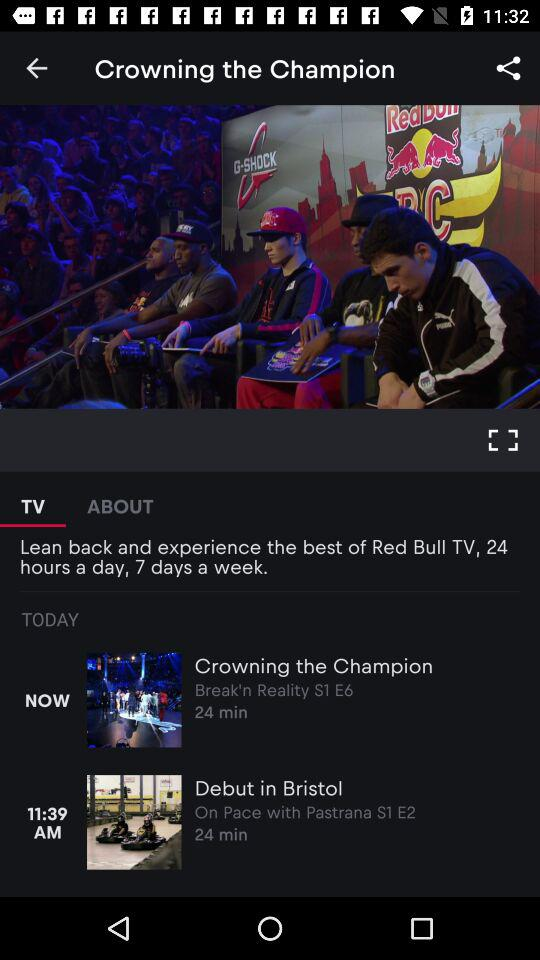Which video is now playing?
When the provided information is insufficient, respond with <no answer>. <no answer> 